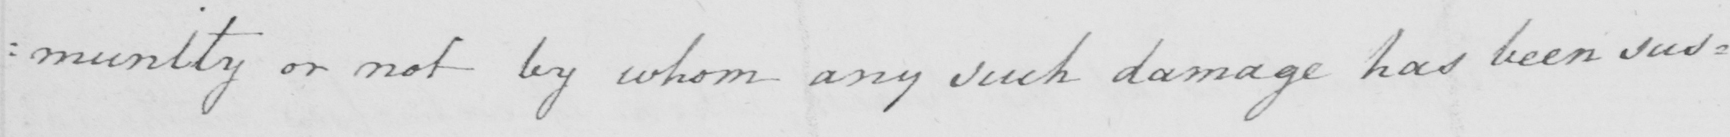What text is written in this handwritten line? : munity or not by whom any such damage has been sus : 